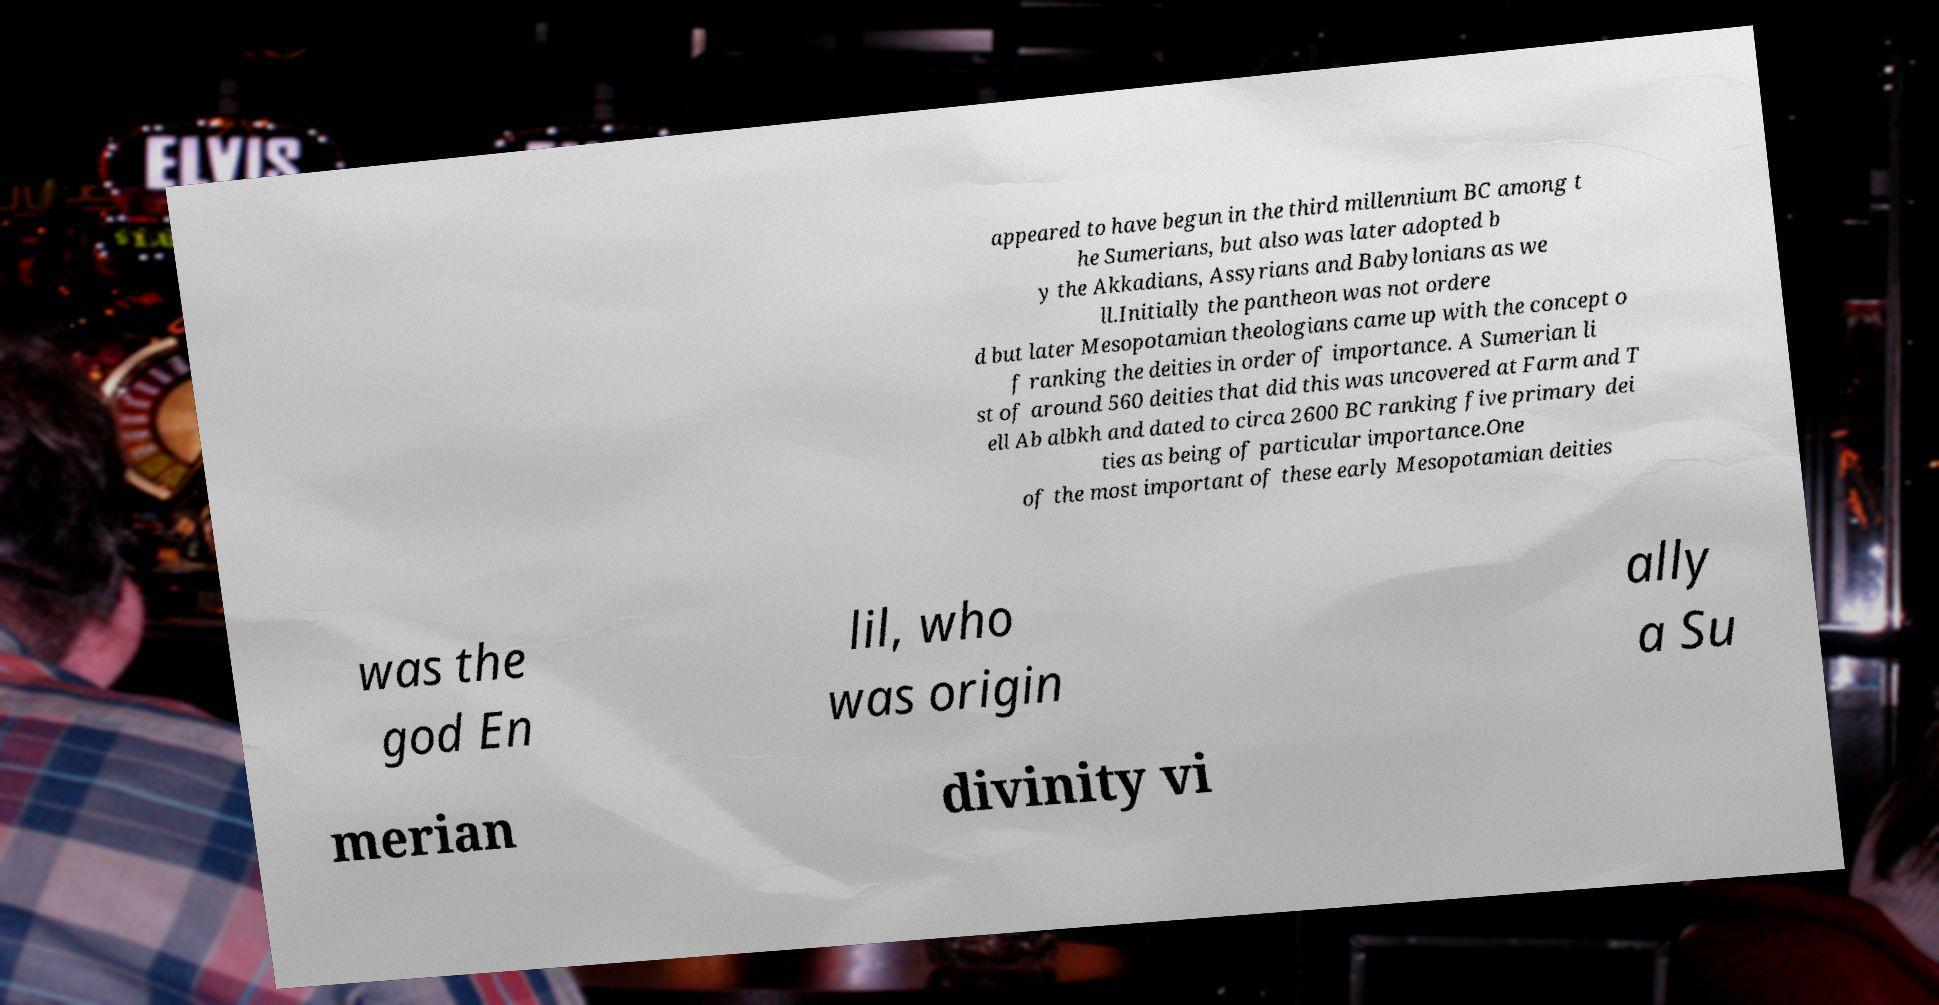Could you assist in decoding the text presented in this image and type it out clearly? appeared to have begun in the third millennium BC among t he Sumerians, but also was later adopted b y the Akkadians, Assyrians and Babylonians as we ll.Initially the pantheon was not ordere d but later Mesopotamian theologians came up with the concept o f ranking the deities in order of importance. A Sumerian li st of around 560 deities that did this was uncovered at Farm and T ell Ab albkh and dated to circa 2600 BC ranking five primary dei ties as being of particular importance.One of the most important of these early Mesopotamian deities was the god En lil, who was origin ally a Su merian divinity vi 